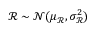Convert formula to latex. <formula><loc_0><loc_0><loc_500><loc_500>\ m a t h s c r R \sim \mathcal { N } ( \mu _ { \ m a t h s c r R } , \sigma _ { \ m a t h s c r R } ^ { 2 } )</formula> 